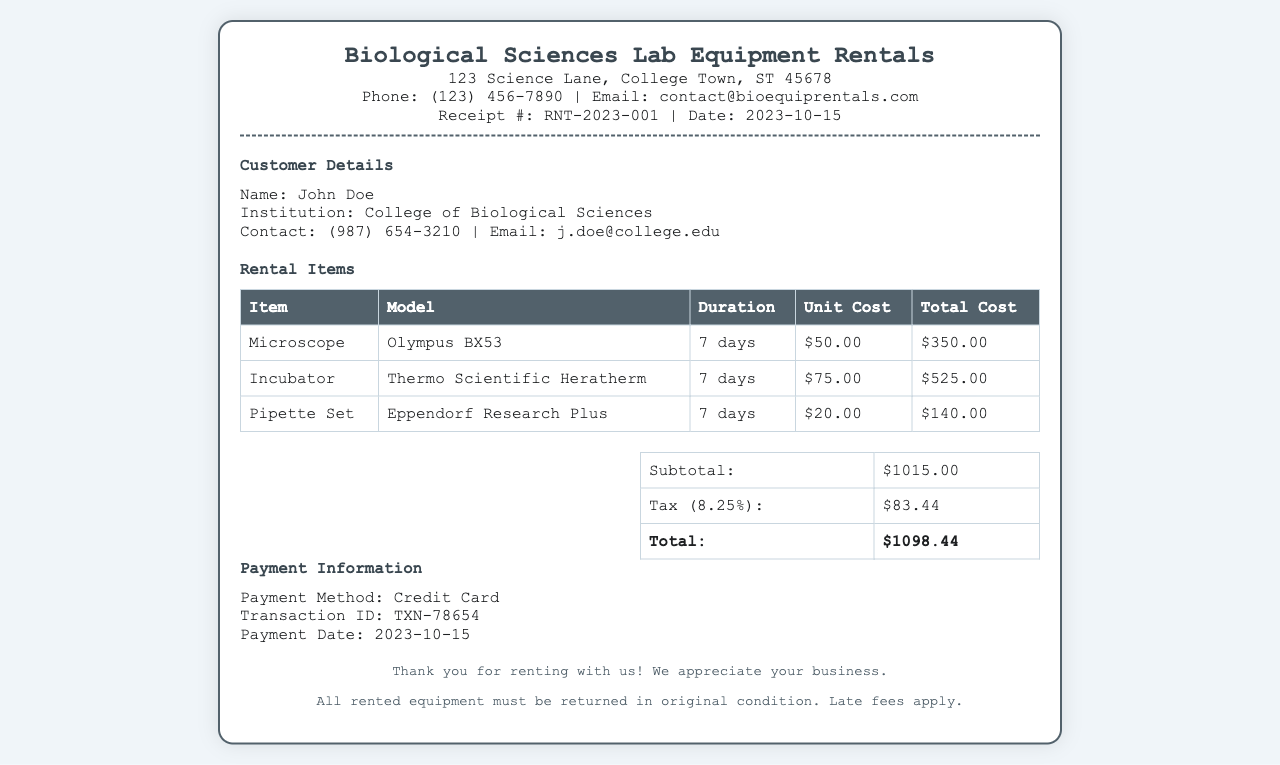What is the receipt number? The receipt number is a unique identifier for the transaction mentioned in the document.
Answer: RNT-2023-001 Who is the customer? The customer's name is mentioned in the document under customer details.
Answer: John Doe What is the total cost of the rental? The total cost is calculated as the sum of the subtotal and tax presented in the summary section.
Answer: $1098.44 What equipment was rented? The document lists all the equipment rented in a table format under rental items.
Answer: Microscope, Incubator, Pipette Set What is the tax rate applied? The tax rate is indicated in the summary section of the receipt.
Answer: 8.25% How many days was the equipment rented for? The duration for which the equipment was rented is specified in the rental items section.
Answer: 7 days What is the payment method used? The payment method is provided in the payment information section of the document.
Answer: Credit Card What is the subtotal before tax? The subtotal is the total cost of all rental items before tax, listed in the summary table.
Answer: $1015.00 When was the payment date? The payment date is mentioned in the payment information section.
Answer: 2023-10-15 